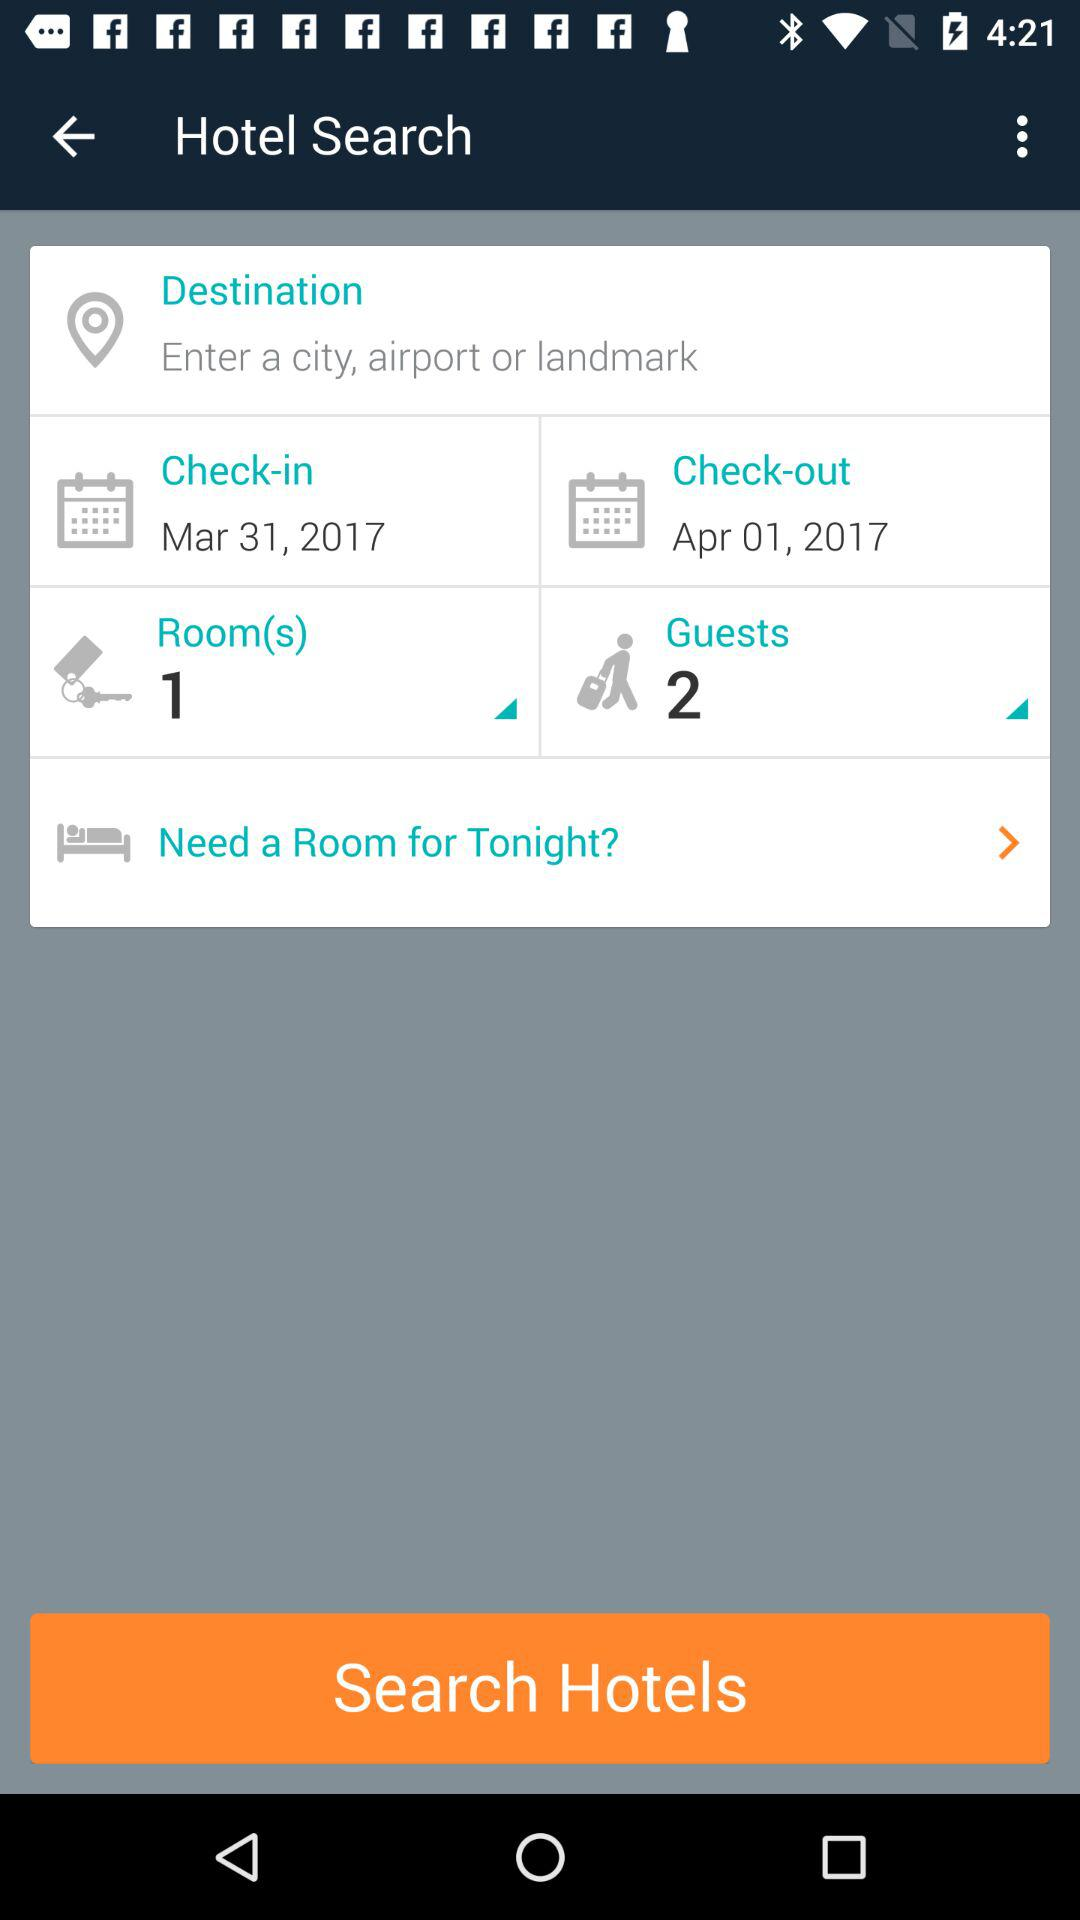How much is the hotel room per night?
When the provided information is insufficient, respond with <no answer>. <no answer> 